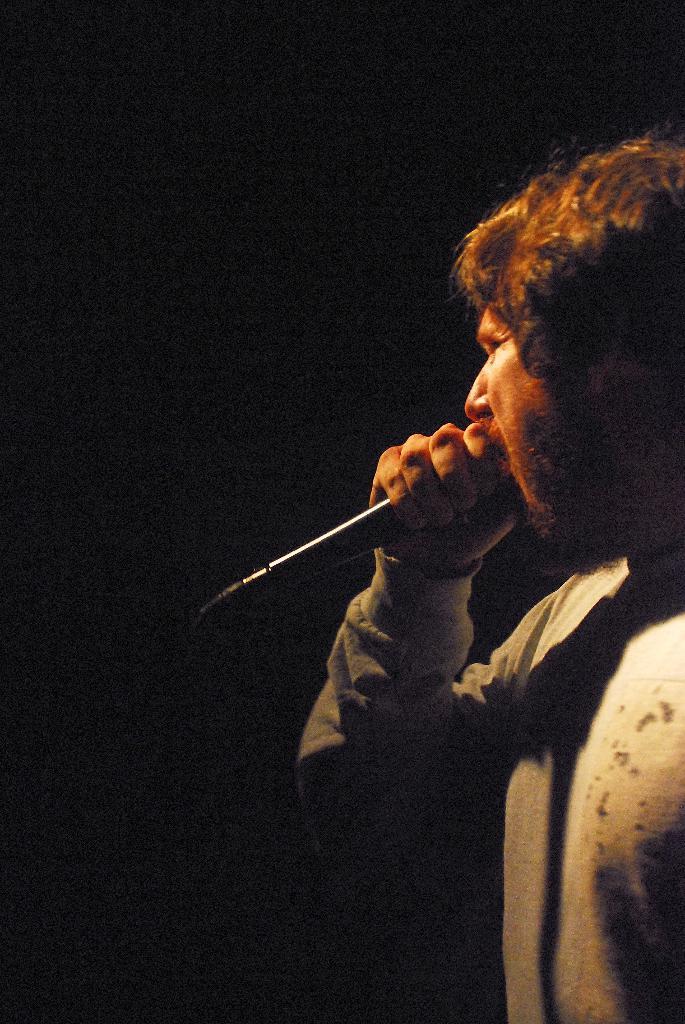Please provide a concise description of this image. In this image I can see a person holding a mike. 